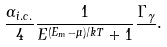Convert formula to latex. <formula><loc_0><loc_0><loc_500><loc_500>\frac { \alpha _ { i . c . } } { 4 } \frac { 1 } { E ^ { ( E _ { m } - \mu ) / k T } + 1 } \frac { \Gamma _ { \gamma } } { } .</formula> 